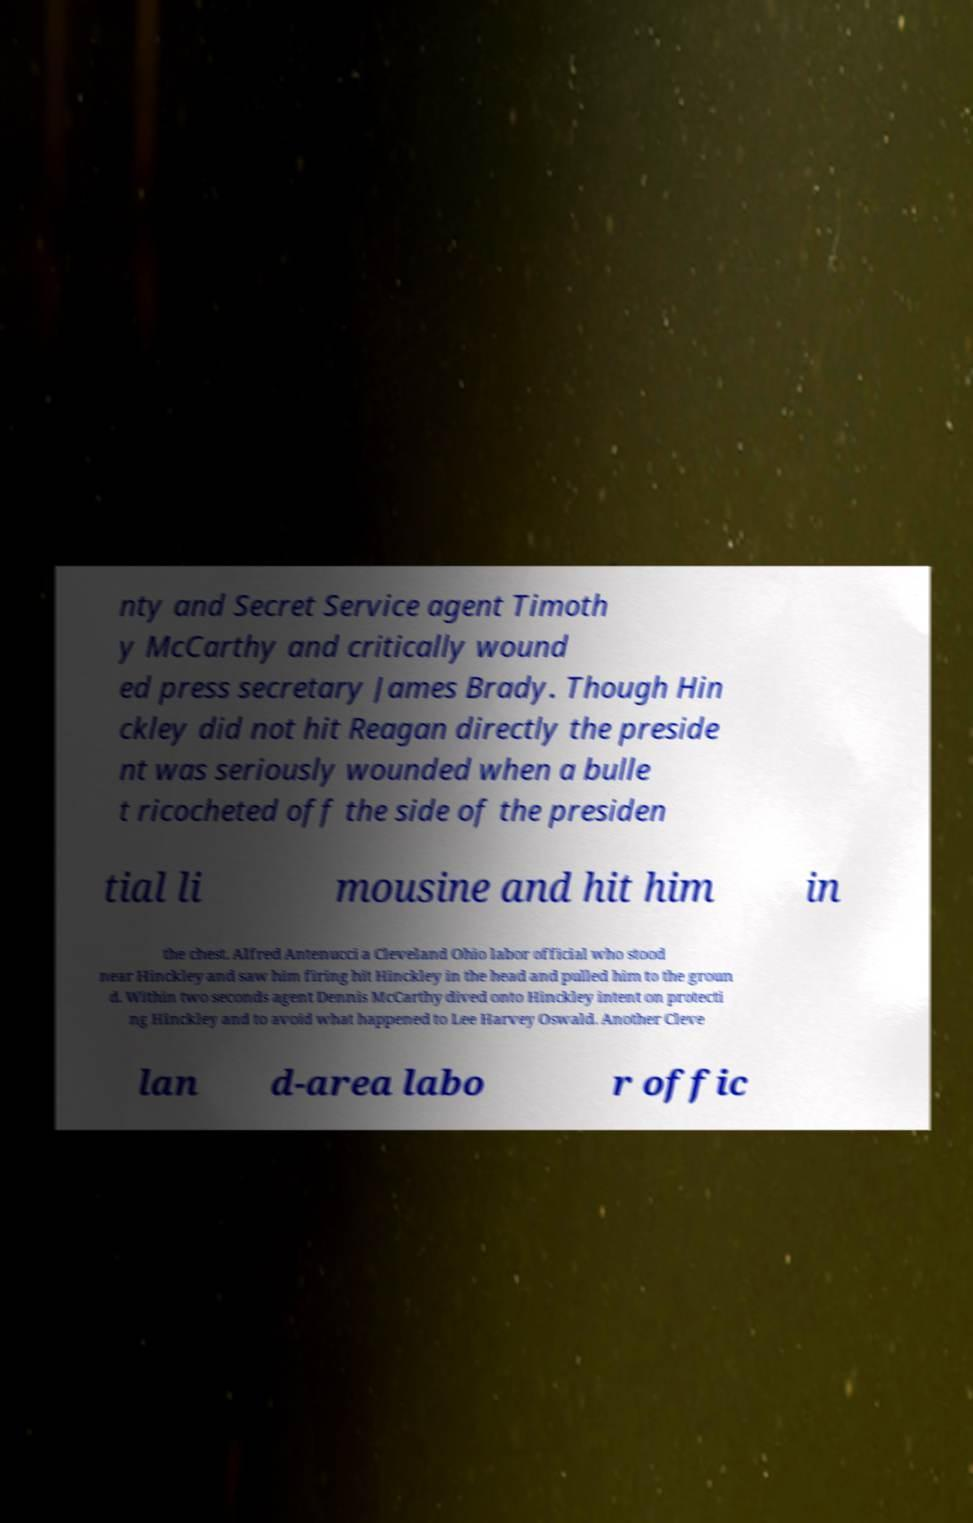Can you accurately transcribe the text from the provided image for me? nty and Secret Service agent Timoth y McCarthy and critically wound ed press secretary James Brady. Though Hin ckley did not hit Reagan directly the preside nt was seriously wounded when a bulle t ricocheted off the side of the presiden tial li mousine and hit him in the chest. Alfred Antenucci a Cleveland Ohio labor official who stood near Hinckley and saw him firing hit Hinckley in the head and pulled him to the groun d. Within two seconds agent Dennis McCarthy dived onto Hinckley intent on protecti ng Hinckley and to avoid what happened to Lee Harvey Oswald. Another Cleve lan d-area labo r offic 